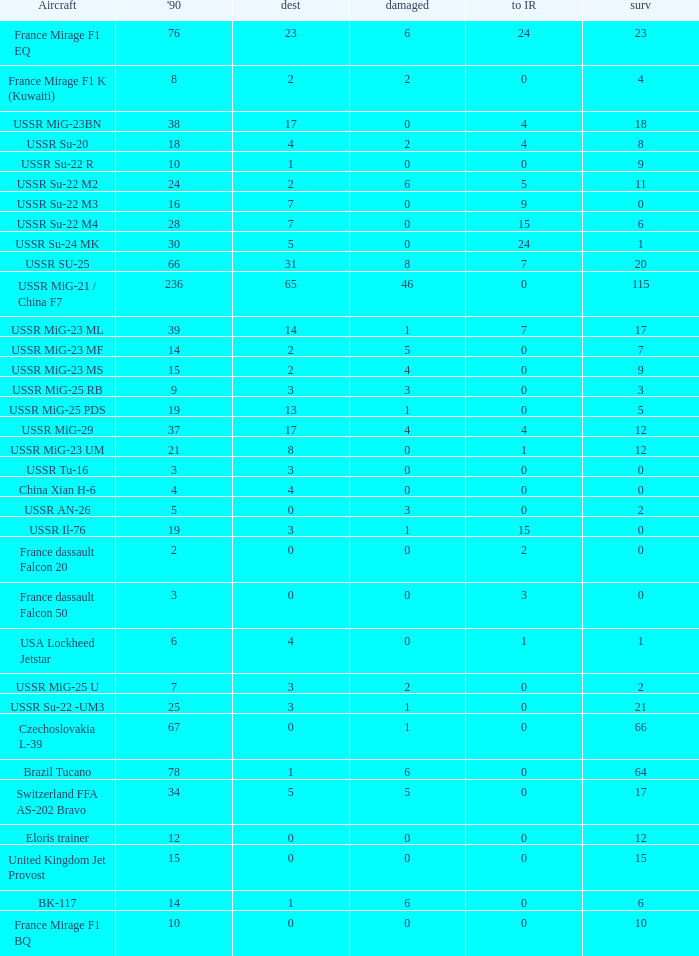If there were 14 in 1990 and 6 survived how many were destroyed? 1.0. 